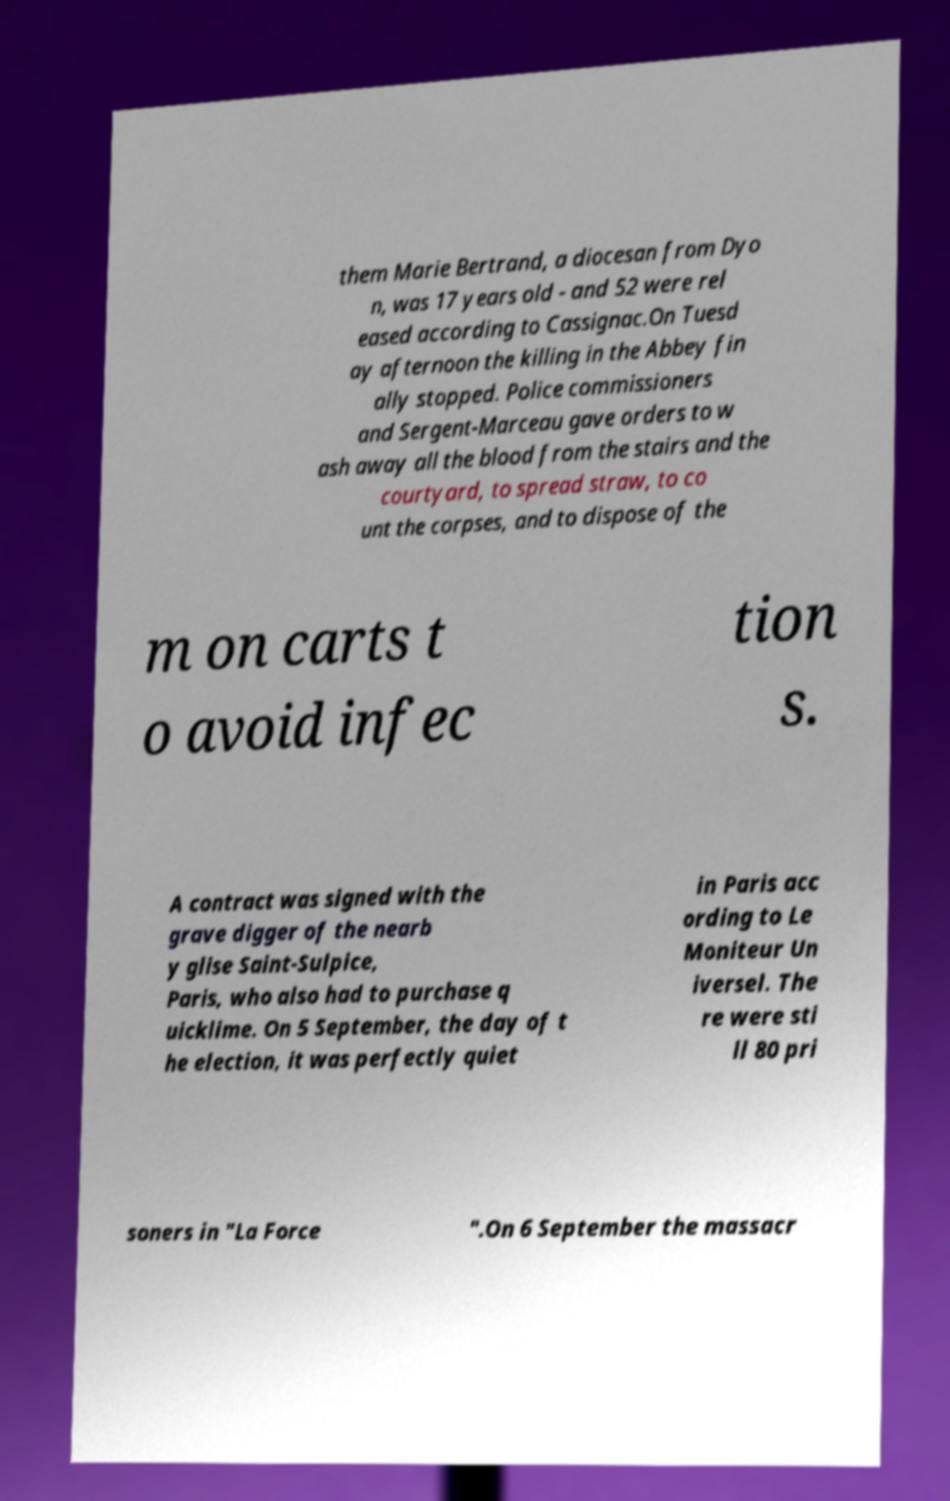I need the written content from this picture converted into text. Can you do that? them Marie Bertrand, a diocesan from Dyo n, was 17 years old - and 52 were rel eased according to Cassignac.On Tuesd ay afternoon the killing in the Abbey fin ally stopped. Police commissioners and Sergent-Marceau gave orders to w ash away all the blood from the stairs and the courtyard, to spread straw, to co unt the corpses, and to dispose of the m on carts t o avoid infec tion s. A contract was signed with the grave digger of the nearb y glise Saint-Sulpice, Paris, who also had to purchase q uicklime. On 5 September, the day of t he election, it was perfectly quiet in Paris acc ording to Le Moniteur Un iversel. The re were sti ll 80 pri soners in "La Force ".On 6 September the massacr 